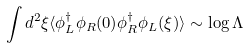Convert formula to latex. <formula><loc_0><loc_0><loc_500><loc_500>\int d ^ { 2 } \xi \langle \phi _ { L } ^ { \dagger } \phi _ { R } ( 0 ) \phi _ { R } ^ { \dagger } \phi _ { L } ( \xi ) \rangle \sim \log \Lambda</formula> 